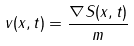Convert formula to latex. <formula><loc_0><loc_0><loc_500><loc_500>v ( x , t ) = \frac { \nabla S ( x , t ) } { m }</formula> 